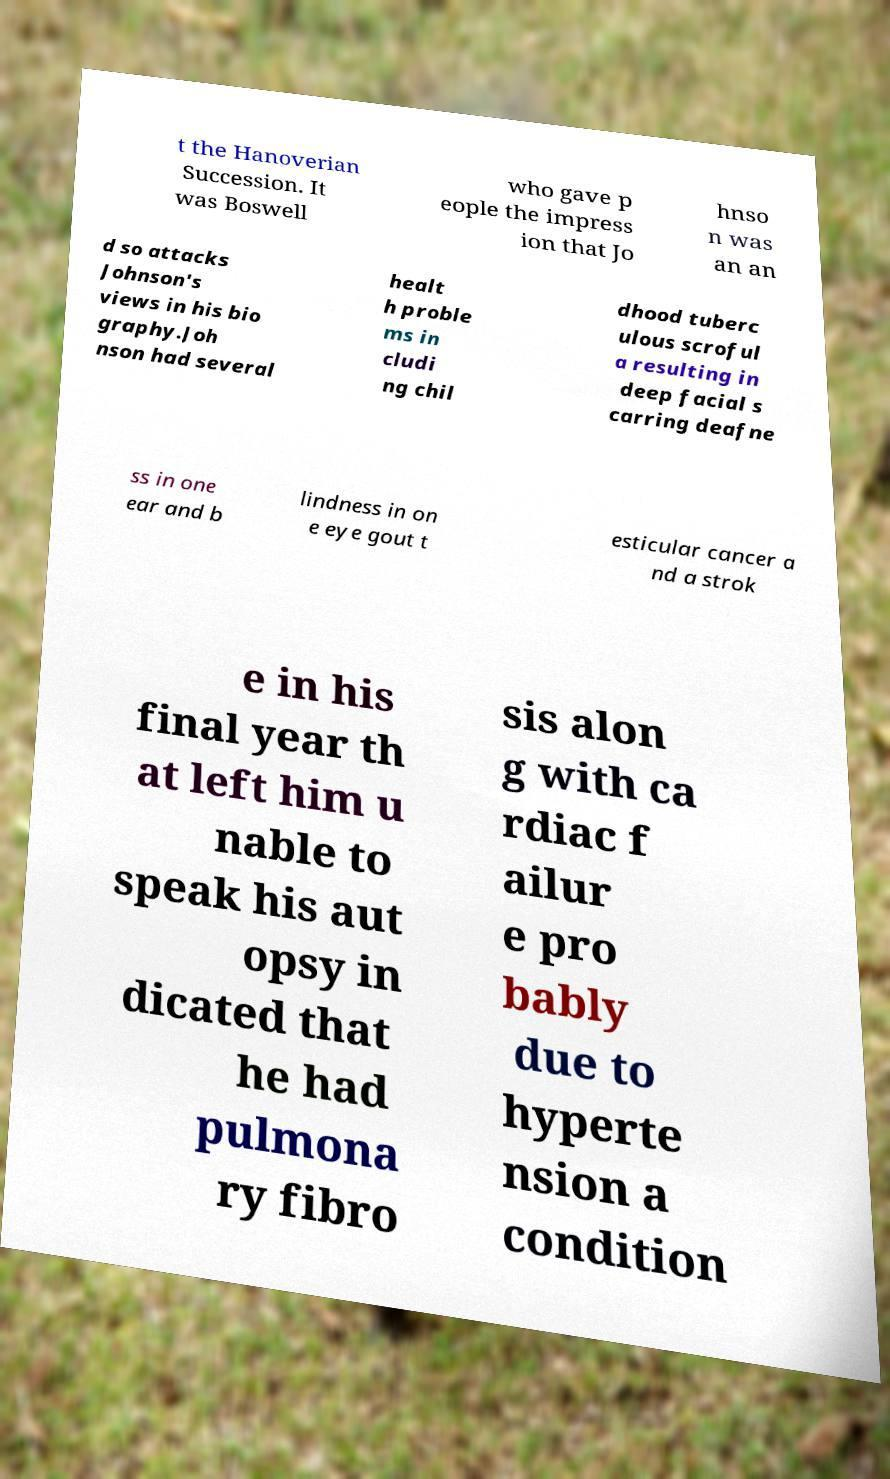Could you extract and type out the text from this image? t the Hanoverian Succession. It was Boswell who gave p eople the impress ion that Jo hnso n was an an d so attacks Johnson's views in his bio graphy.Joh nson had several healt h proble ms in cludi ng chil dhood tuberc ulous scroful a resulting in deep facial s carring deafne ss in one ear and b lindness in on e eye gout t esticular cancer a nd a strok e in his final year th at left him u nable to speak his aut opsy in dicated that he had pulmona ry fibro sis alon g with ca rdiac f ailur e pro bably due to hyperte nsion a condition 